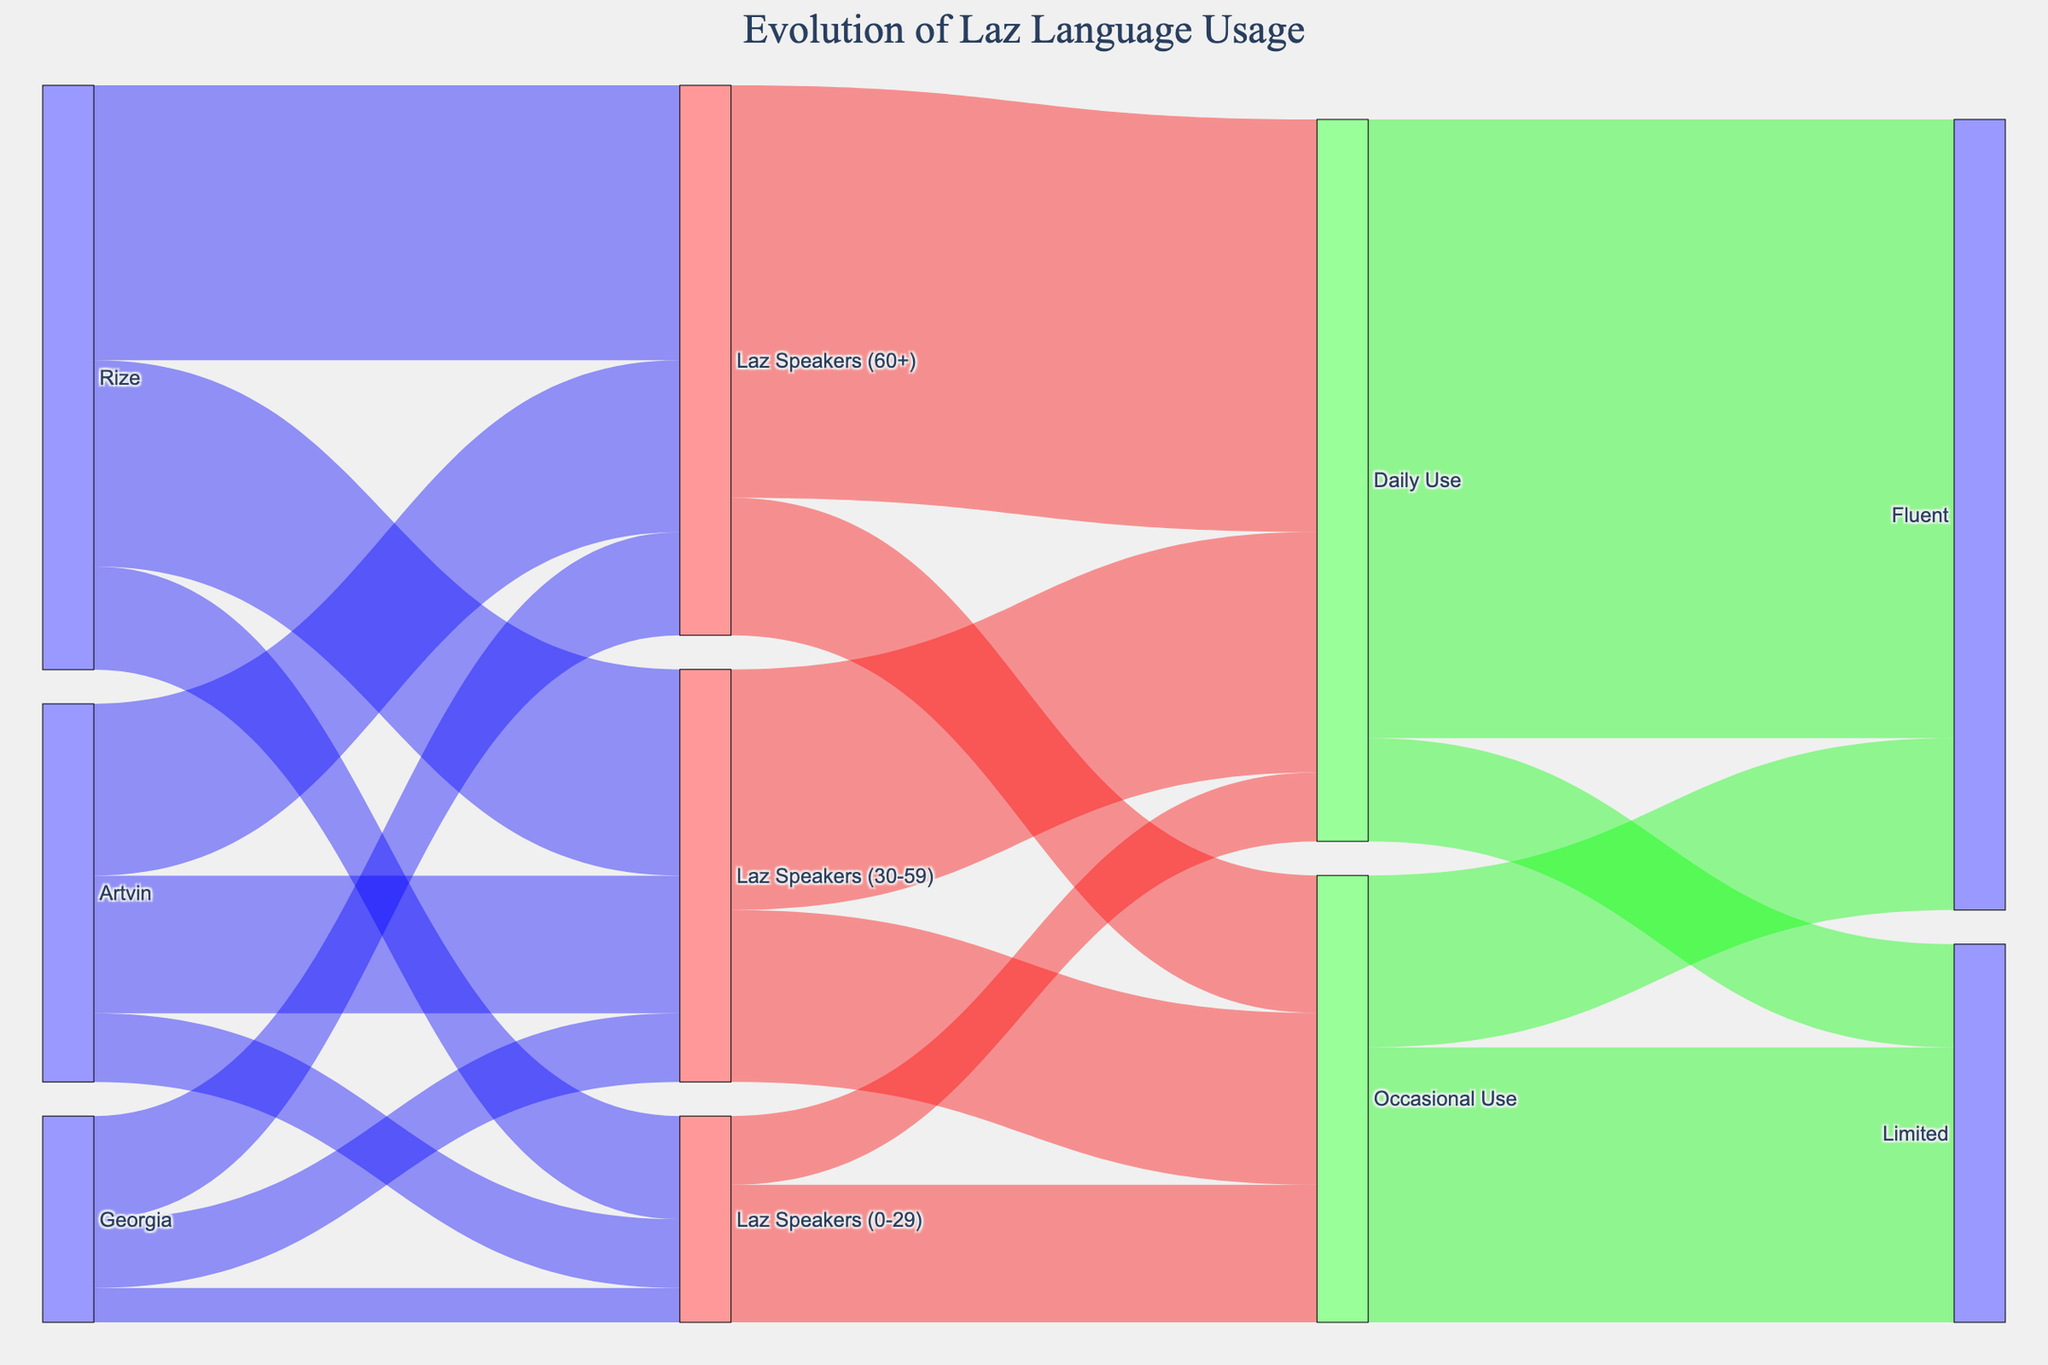How many Laz speakers aged 60+ are in Rize? The diagram shows the flow from Rize to Laz Speakers (60+). The value for this flow is 8000.
Answer: 8000 Which age group has the highest number of Laz speakers in Georgia? By examining the flows from Georgia, we find Laz Speakers (60+) has a value of 3000, Laz Speakers (30-59) has 2000, and Laz Speakers (0-29) has 1000. The highest value is the 60+ group with 3000.
Answer: 60+ What is the total number of Laz speakers aged 30-59 across all areas? To find the total, add the values from Rize (6000), Artvin (4000), and Georgia (2000): 6000 + 4000 + 2000 = 12000.
Answer: 12000 How many Laz speakers aged 0-29 in Artvin use the language occasionally? First, find Laz Speakers (0-29) in Artvin (2000), and then use the flow from Laz Speakers (0-29) to Occasional Use, which totals 4000 (sum of flows from all regions). This can't be directly inferred as it's aggregated. Assumptions or additional detail would be required.
Answer: Not directly answerable Compare the number of fluent speakers with occasional use against daily use. Which is higher? Fluent speakers with occasional use have 5000, whereas those with daily use have 18000. 18000 is higher than 5000.
Answer: Daily use What is the sum of Laz speakers in all age groups across Rize and Artvin? Sum each group for Rize (8000 + 6000 + 3000 = 17000) and Artvin (5000 + 4000 + 2000 = 11000); then sum these totals: 17000 + 11000 = 28000.
Answer: 28000 Which age group has the lowest number of Laz speakers? By examining all age groups across all regions: (0-29) in Rize (3000), Artvin (2000), Georgia (1000), total is 6000, which is the lowest among the age groups.
Answer: 0-29 How many Laz speakers aged 60+ use the language daily? Follow the flow from Laz Speakers (60+) to Daily Use, which is 12000.
Answer: 12000 